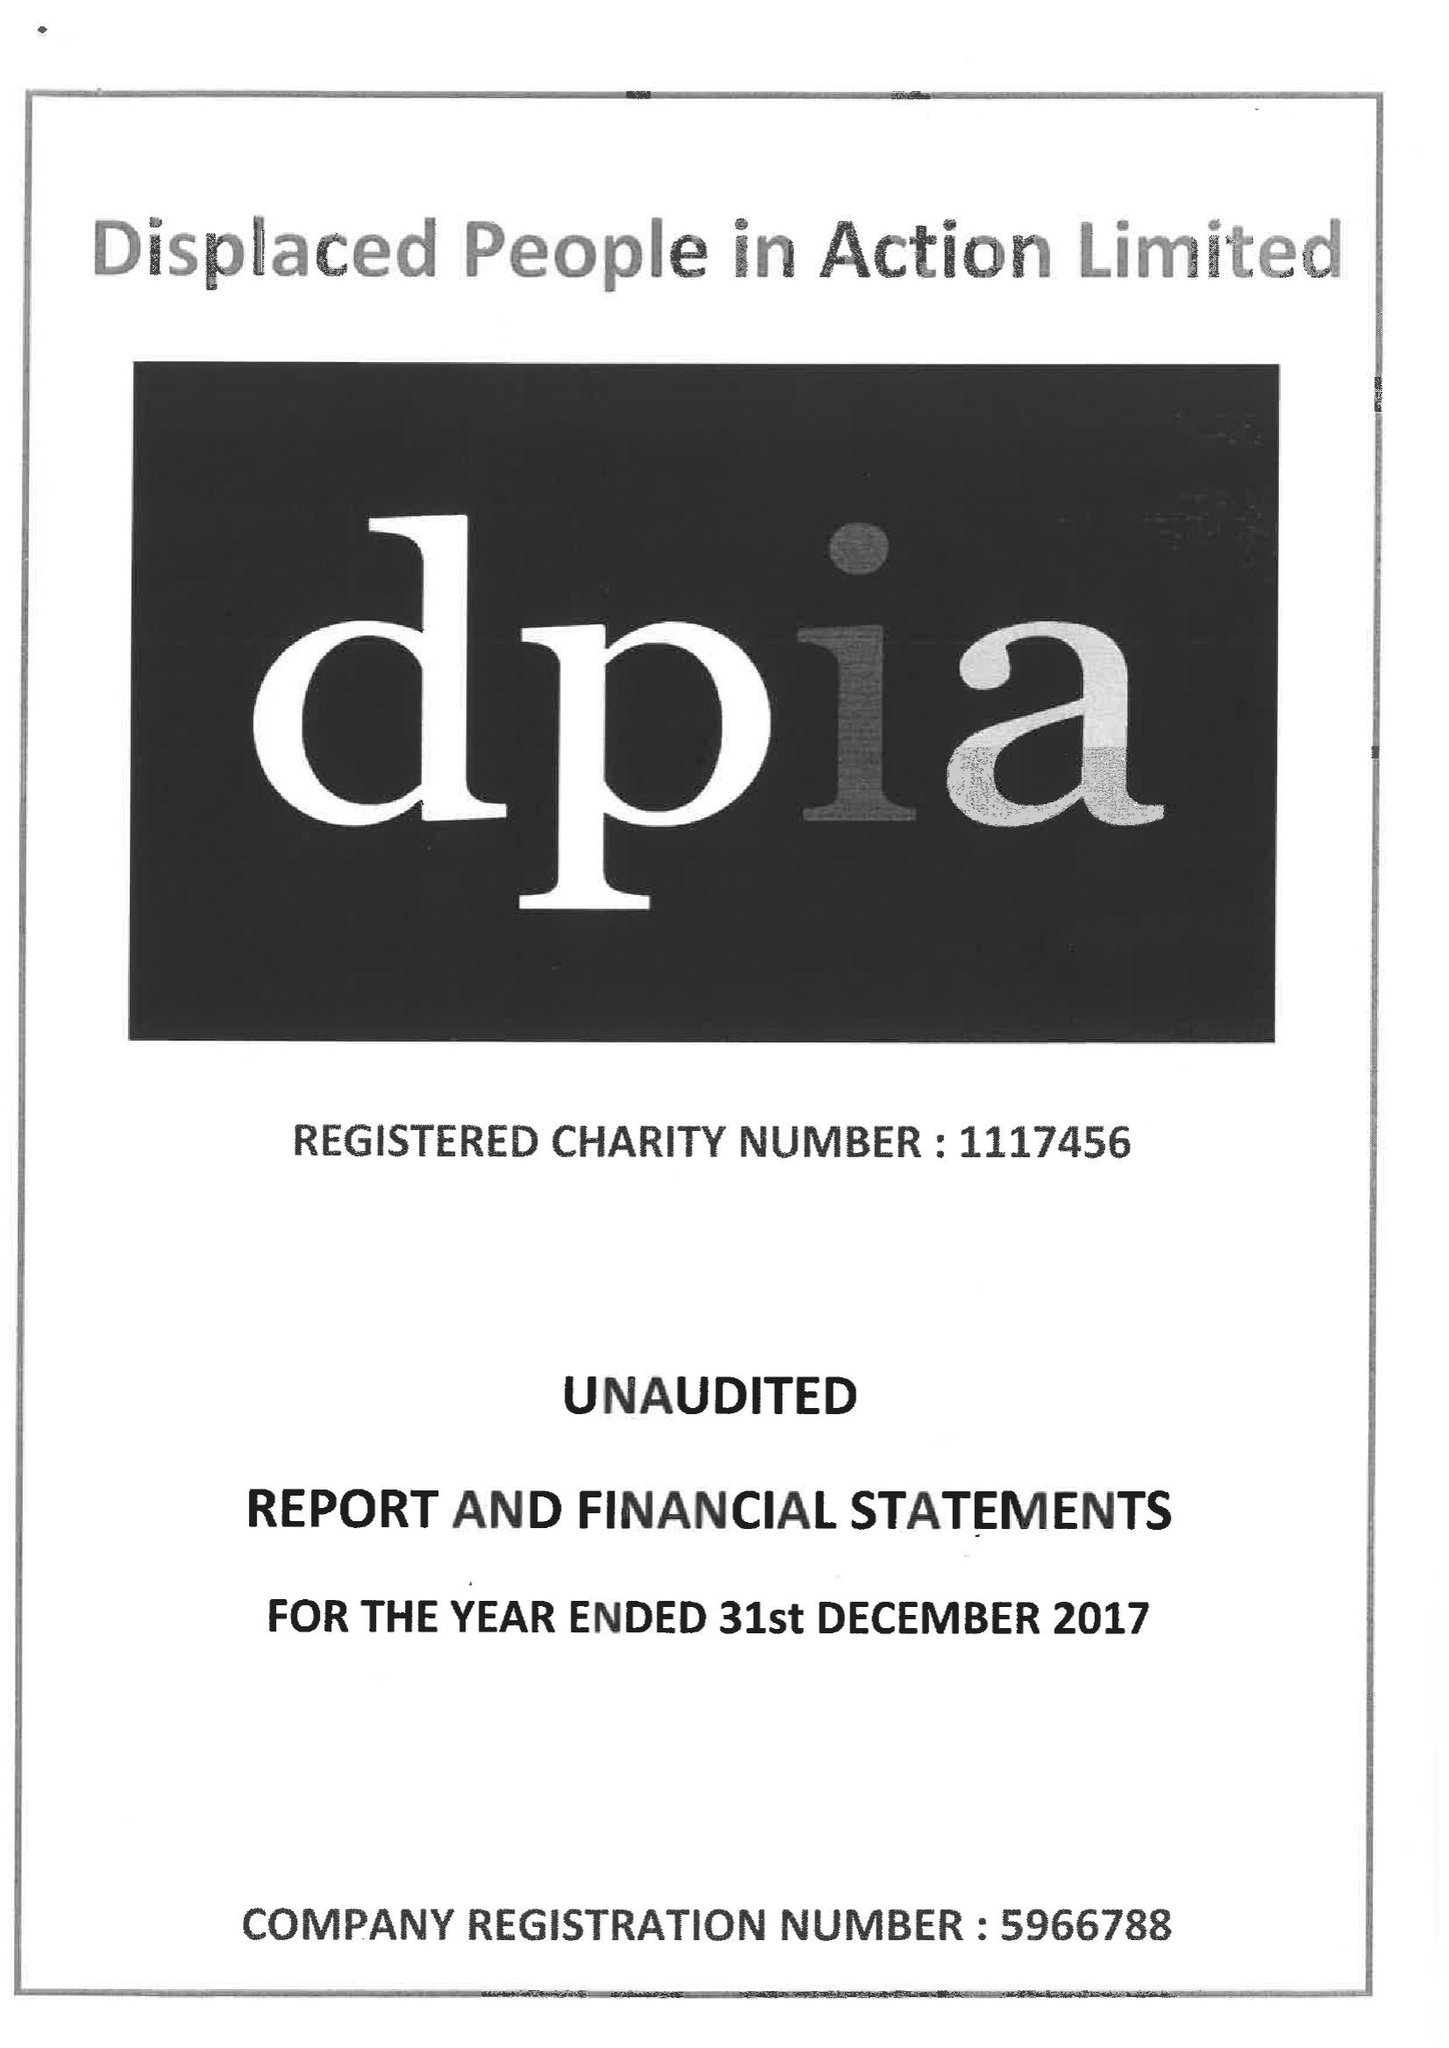What is the value for the report_date?
Answer the question using a single word or phrase. 2017-12-31 